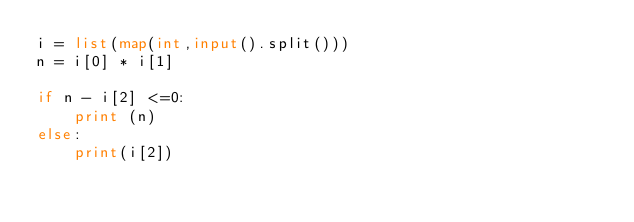<code> <loc_0><loc_0><loc_500><loc_500><_Python_>i = list(map(int,input().split()))
n = i[0] * i[1]

if n - i[2] <=0:
    print (n)
else:
    print(i[2])
</code> 